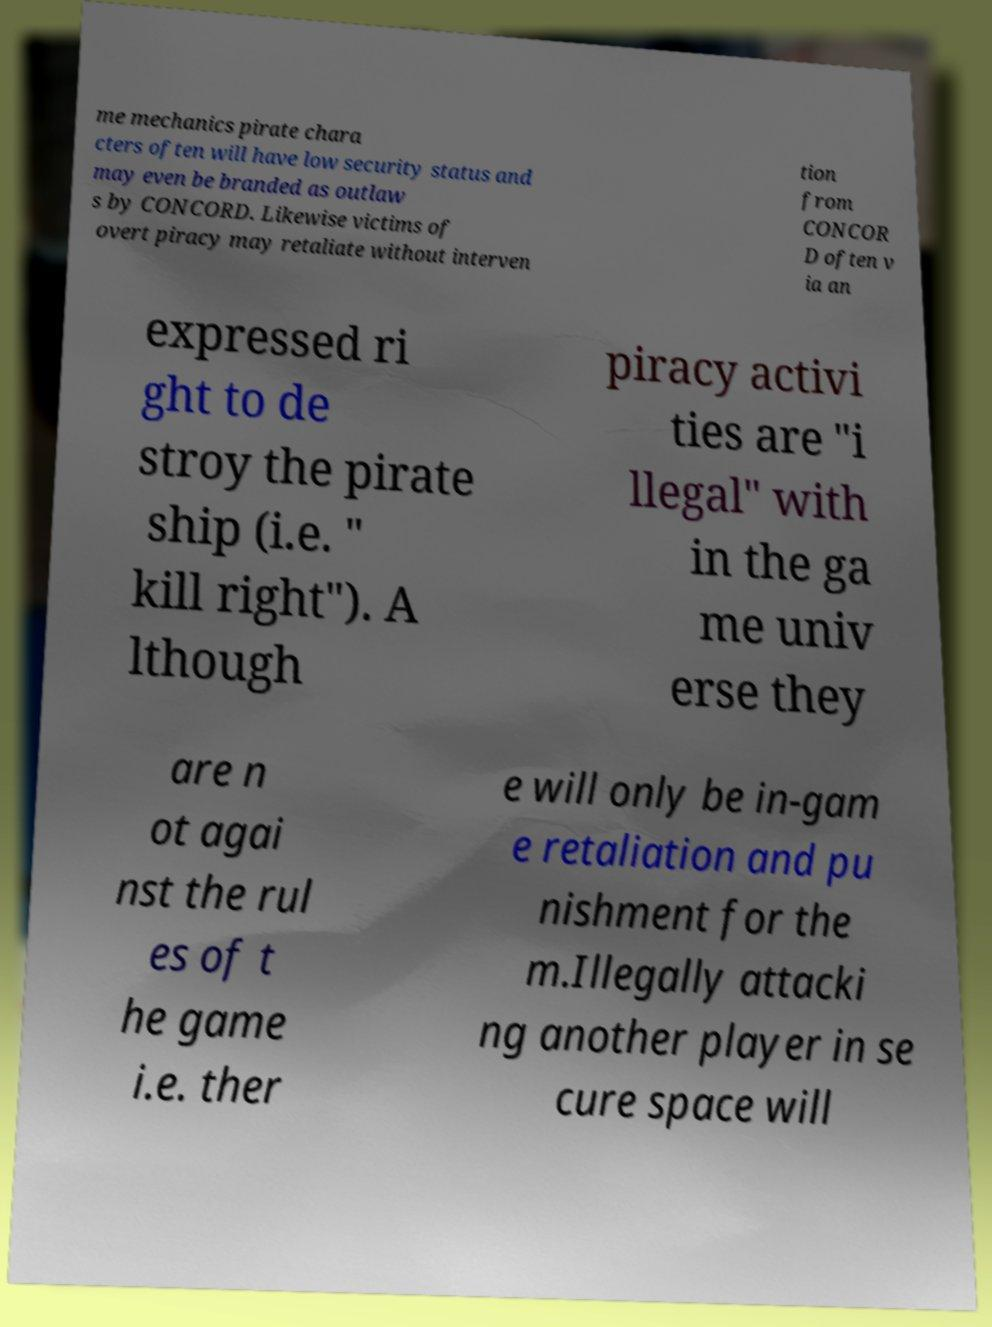Could you assist in decoding the text presented in this image and type it out clearly? me mechanics pirate chara cters often will have low security status and may even be branded as outlaw s by CONCORD. Likewise victims of overt piracy may retaliate without interven tion from CONCOR D often v ia an expressed ri ght to de stroy the pirate ship (i.e. " kill right"). A lthough piracy activi ties are "i llegal" with in the ga me univ erse they are n ot agai nst the rul es of t he game i.e. ther e will only be in-gam e retaliation and pu nishment for the m.Illegally attacki ng another player in se cure space will 